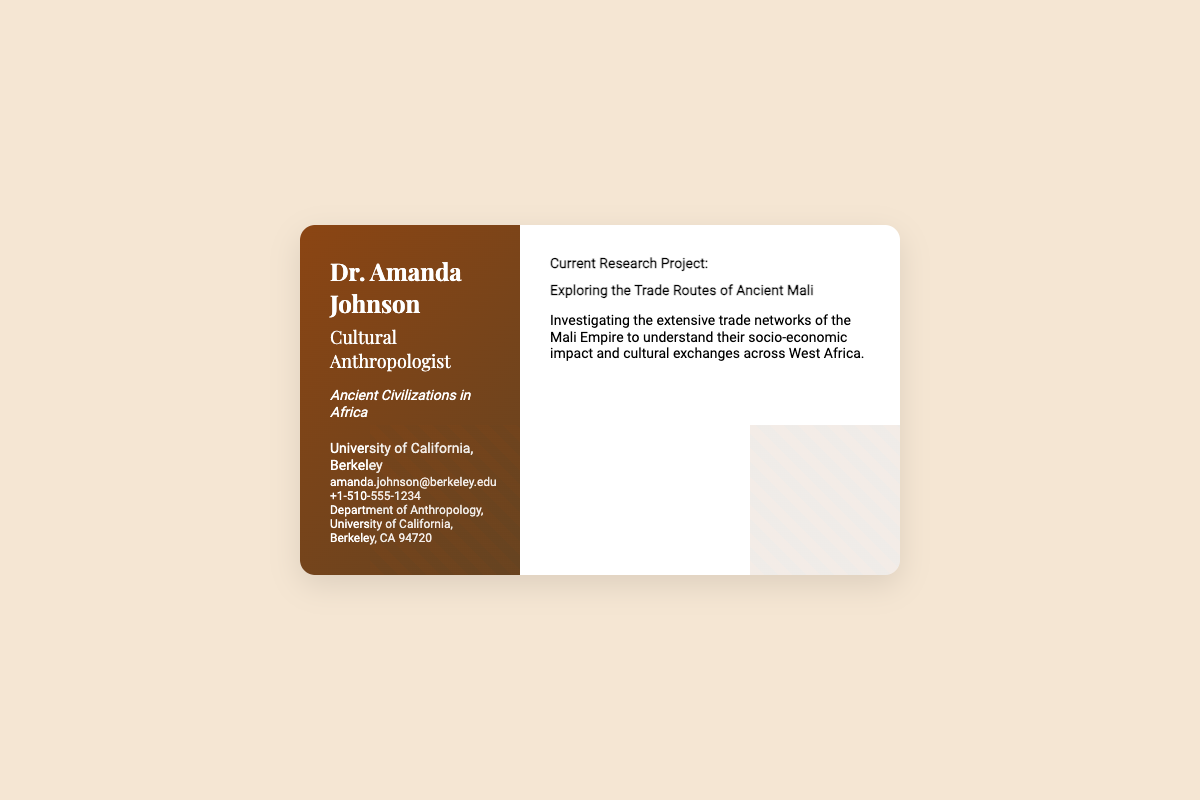What is the name of the researcher? The researcher is identified as Dr. Amanda Johnson in the document.
Answer: Dr. Amanda Johnson What is Dr. Johnson's specialization? The document specifies that her specialization is "Ancient Civilizations in Africa."
Answer: Ancient Civilizations in Africa What is the title of the current research project? The title of the project is clearly stated as "Exploring the Trade Routes of Ancient Mali."
Answer: Exploring the Trade Routes of Ancient Mali Which university is Dr. Johnson affiliated with? The document mentions Dr. Johnson's affiliation as "University of California, Berkeley."
Answer: University of California, Berkeley What email address is listed for Dr. Johnson? The document provides the email address for contact as "amanda.johnson@berkeley.edu."
Answer: amanda.johnson@berkeley.edu What is the focus of the current research project? The document describes the focus of the project in terms of investigating trade networks and their impact across West Africa.
Answer: Investigating the extensive trade networks of the Mali Empire How many phone numbers are listed? The document lists a single phone number for Dr. Johnson, indicating that there is one contact number provided.
Answer: One What type of document is this? This document is a business card that contains professional information about Dr. Johnson.
Answer: Business card What design elements are featured in the card? The card includes subtle geometric designs inspired by African art as part of its visual aesthetics.
Answer: Geometric designs inspired by African art 